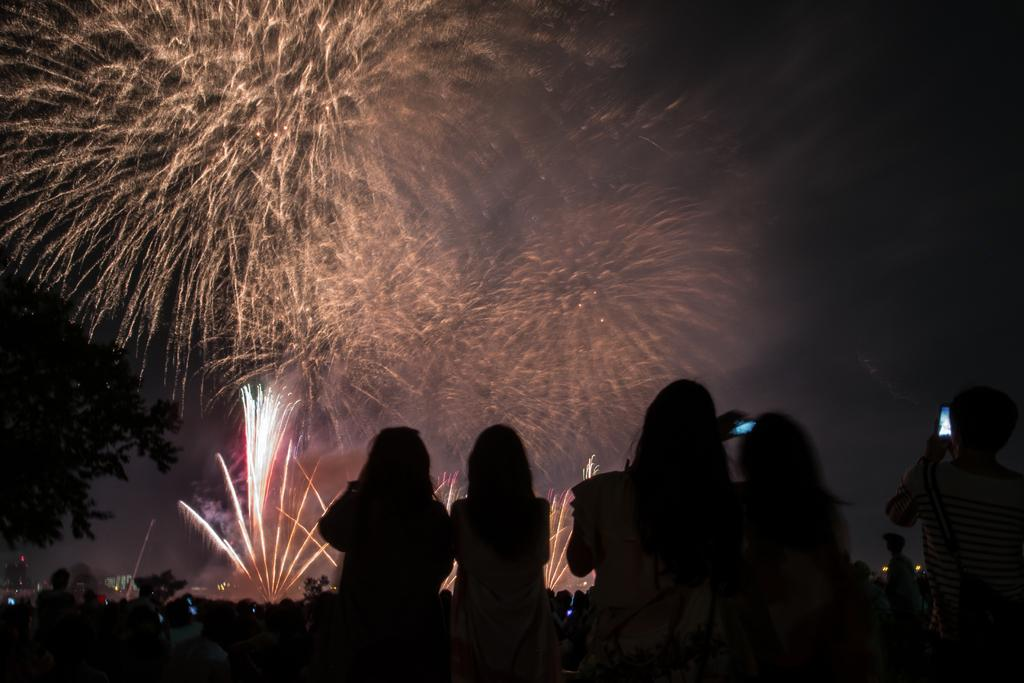What is the main subject of the image? The main subject of the image is women. What are the women doing in the image? The women are sitting in the image. What event are the women watching? The women are watching a firecracker show. What type of experience does the minister have with firecrackers? There is no minister present in the image, and therefore no information about their experience with firecrackers can be determined. 